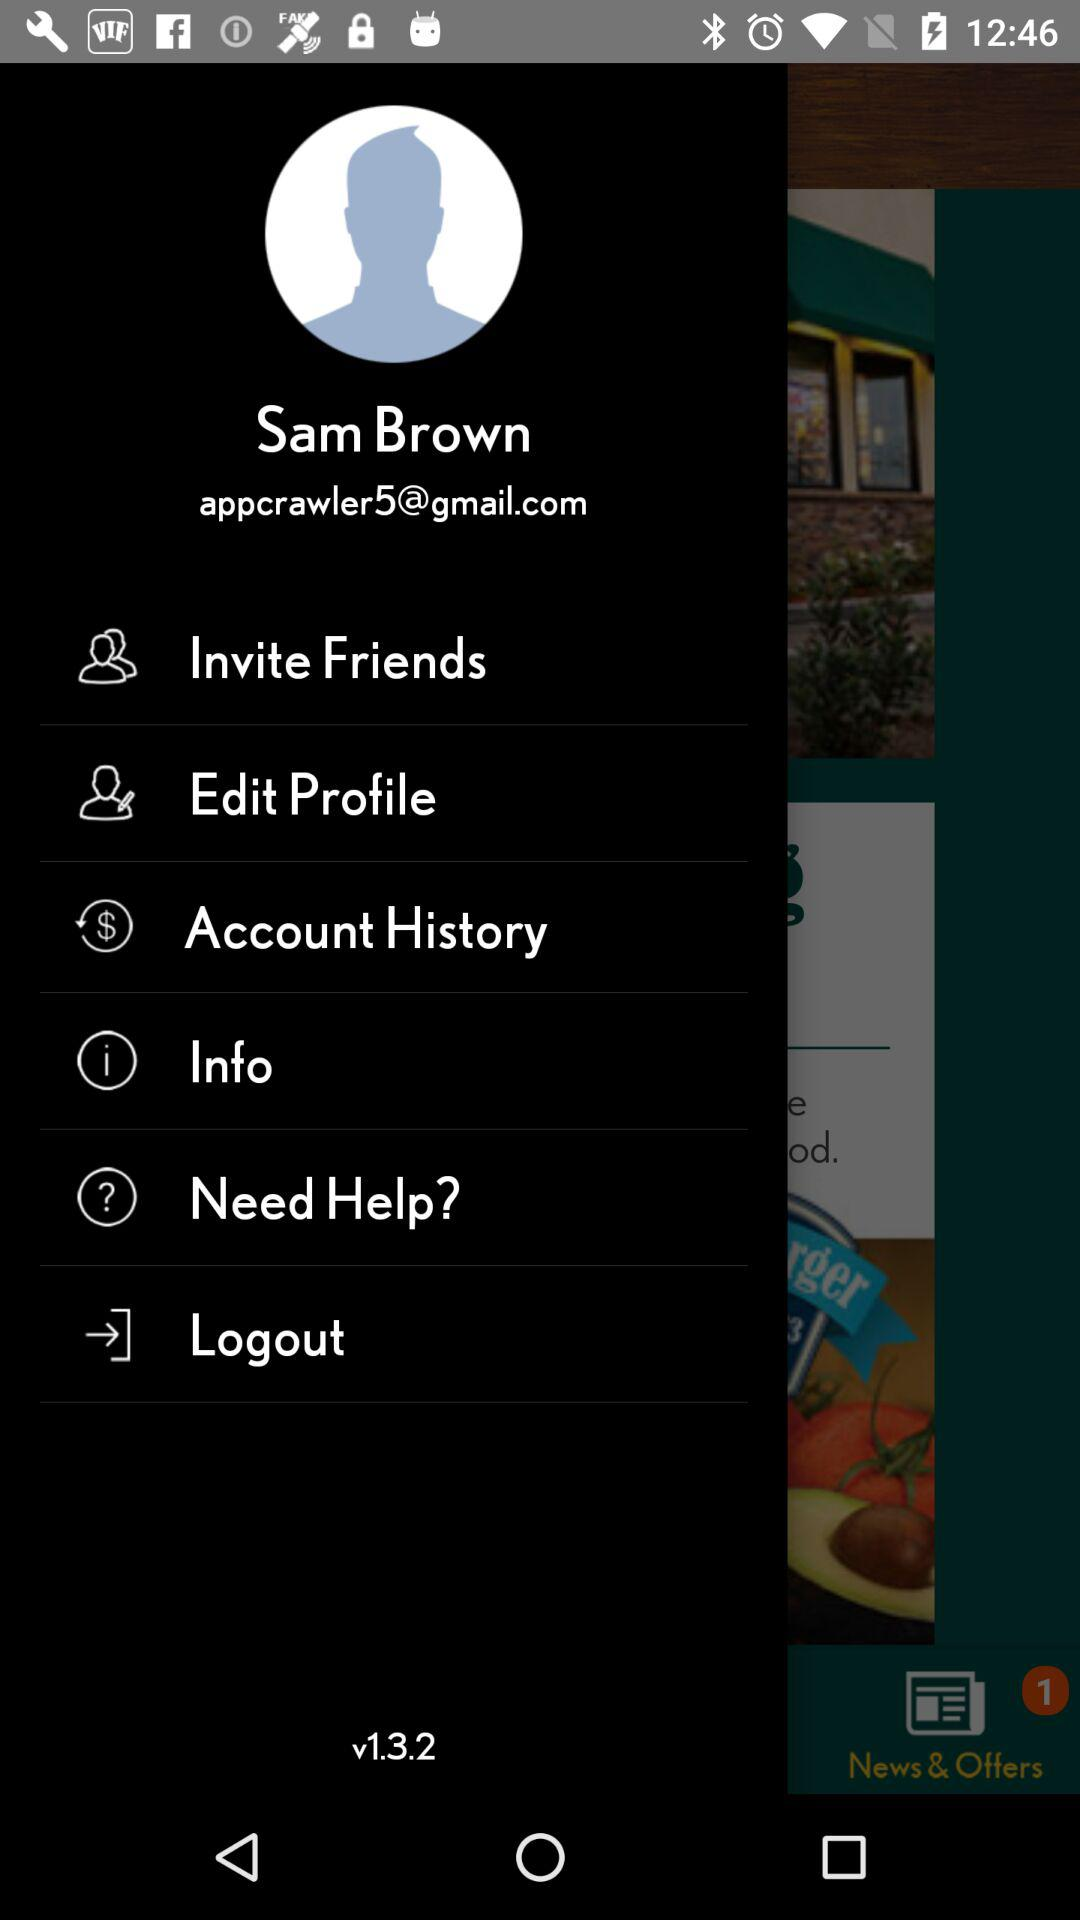Which version of the application is this? The version is v1.3.2. 